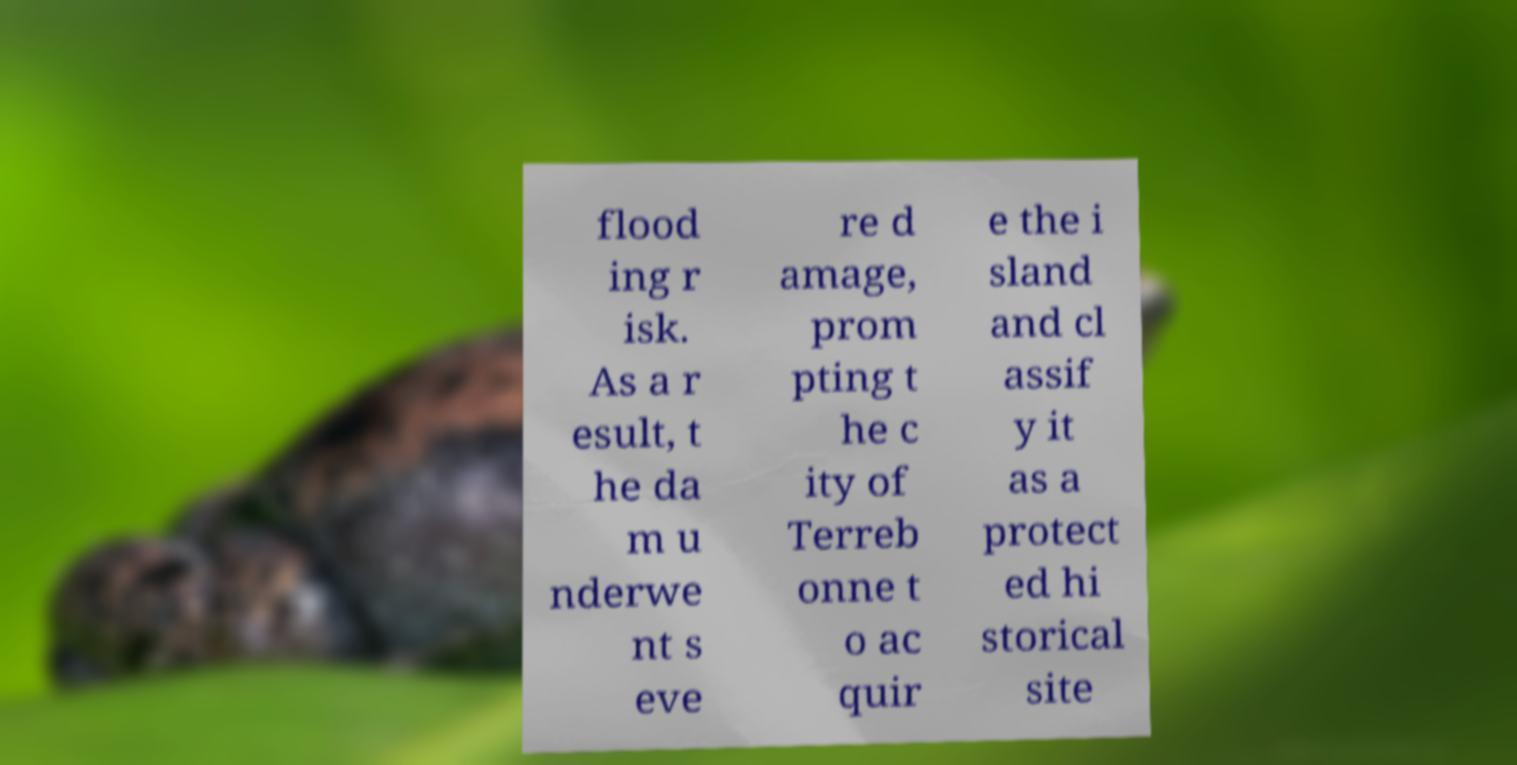For documentation purposes, I need the text within this image transcribed. Could you provide that? flood ing r isk. As a r esult, t he da m u nderwe nt s eve re d amage, prom pting t he c ity of Terreb onne t o ac quir e the i sland and cl assif y it as a protect ed hi storical site 